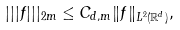Convert formula to latex. <formula><loc_0><loc_0><loc_500><loc_500>| | | f | | | _ { 2 m } \leq C _ { d , m } \| f \| _ { L ^ { 2 } ( \mathbb { R } ^ { d } ) } ,</formula> 